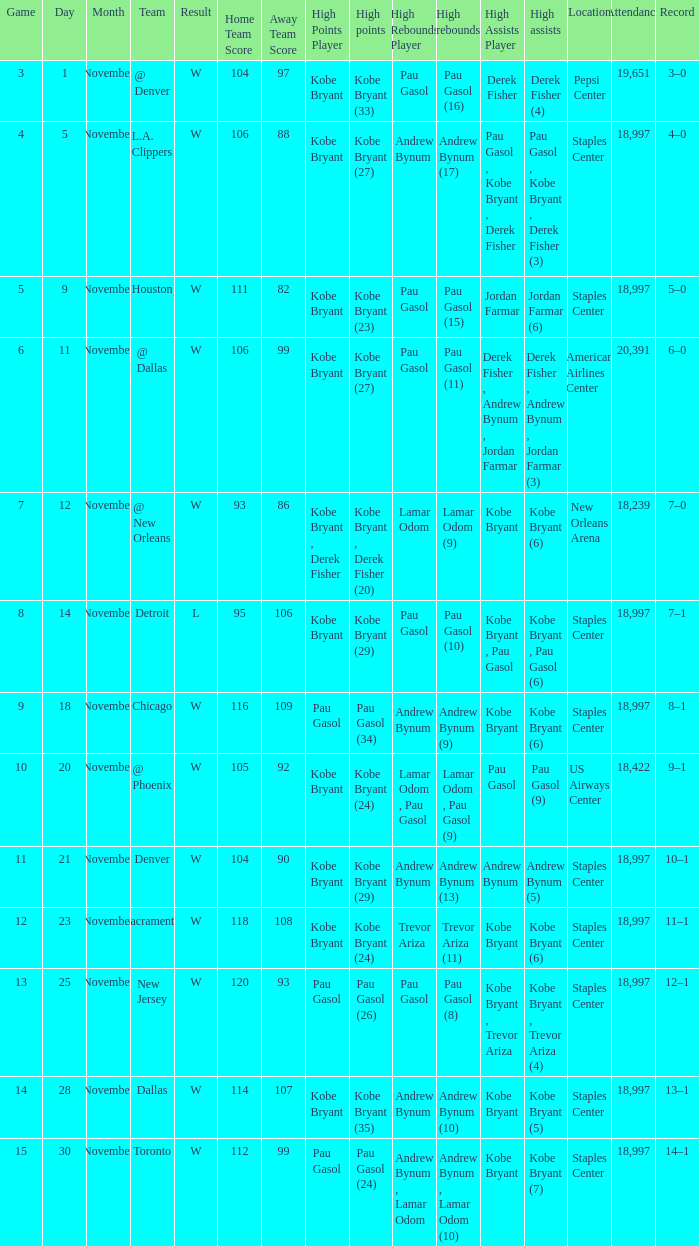What is High Assists, when High Points is "Kobe Bryant (27)", and when High Rebounds is "Pau Gasol (11)"? Derek Fisher , Andrew Bynum , Jordan Farmar (3). 